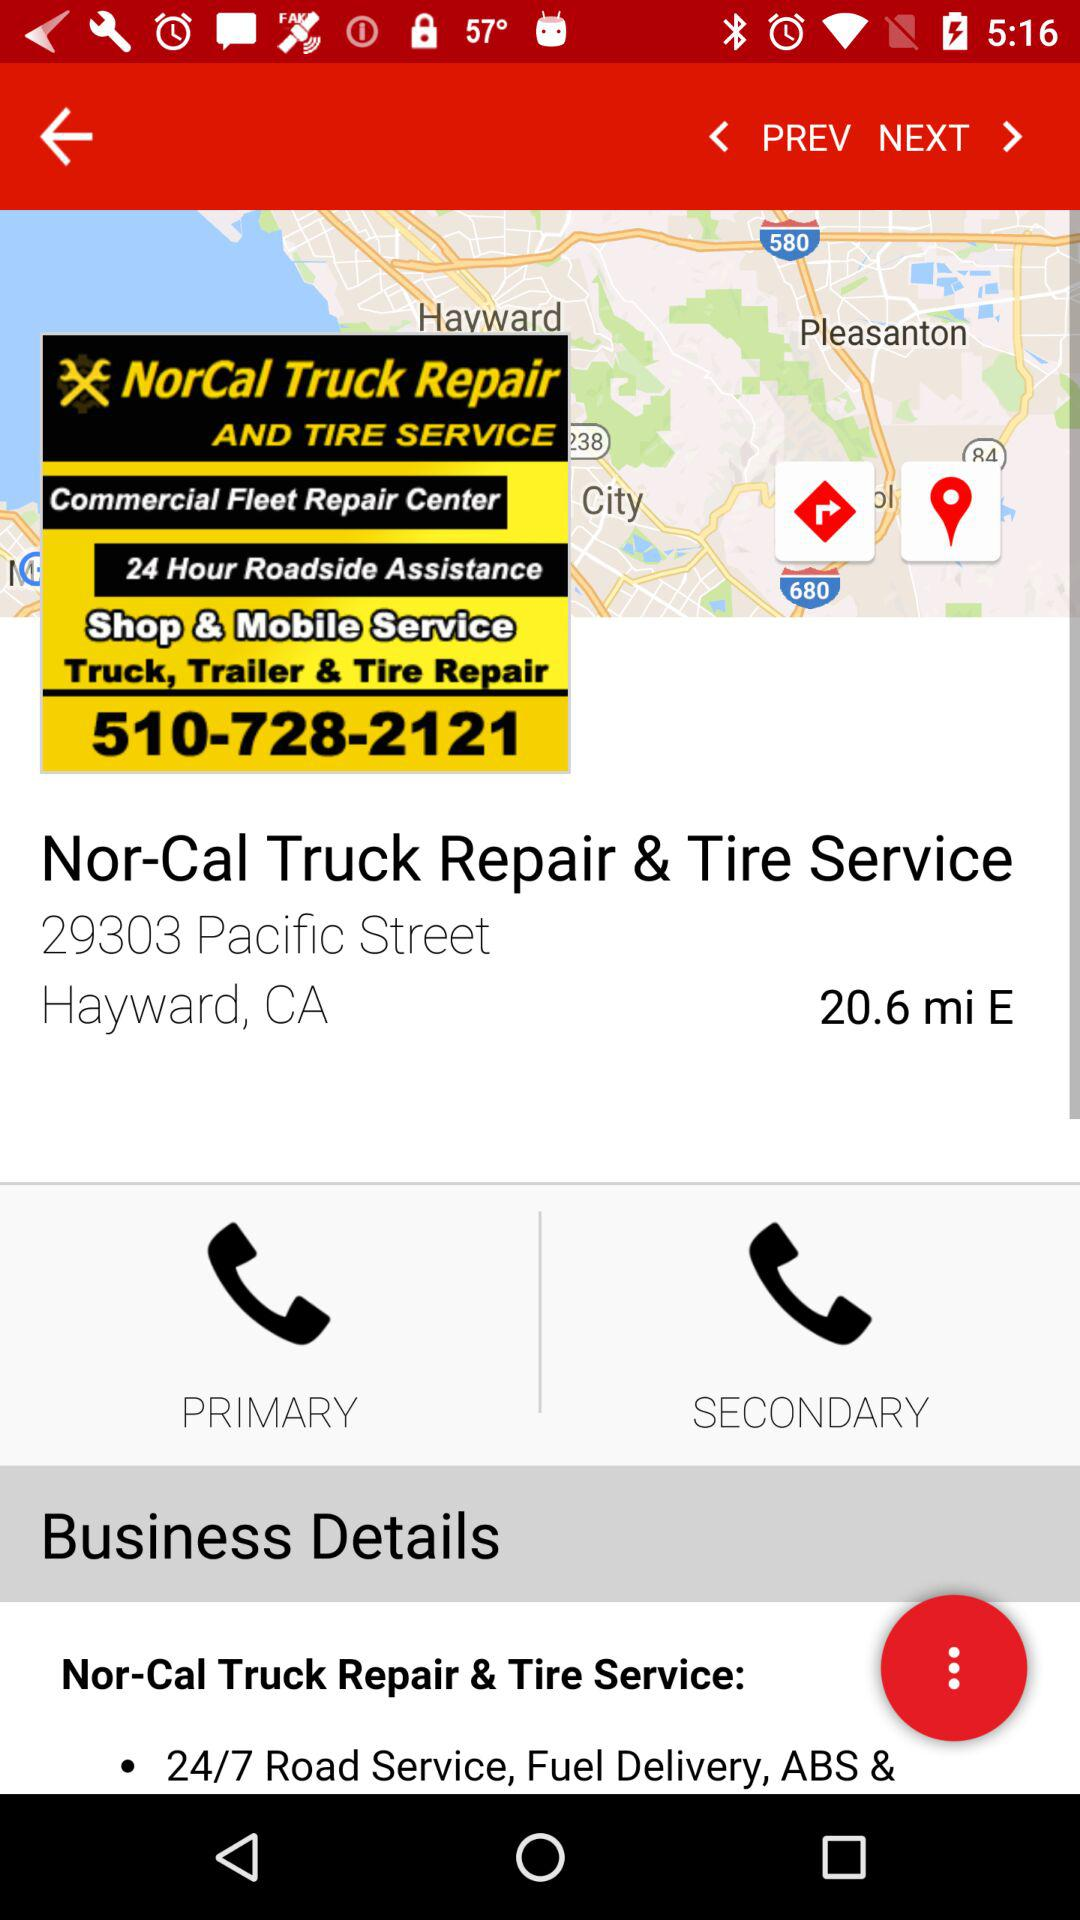What is the contact number? The contact number is 510-728-2121. 